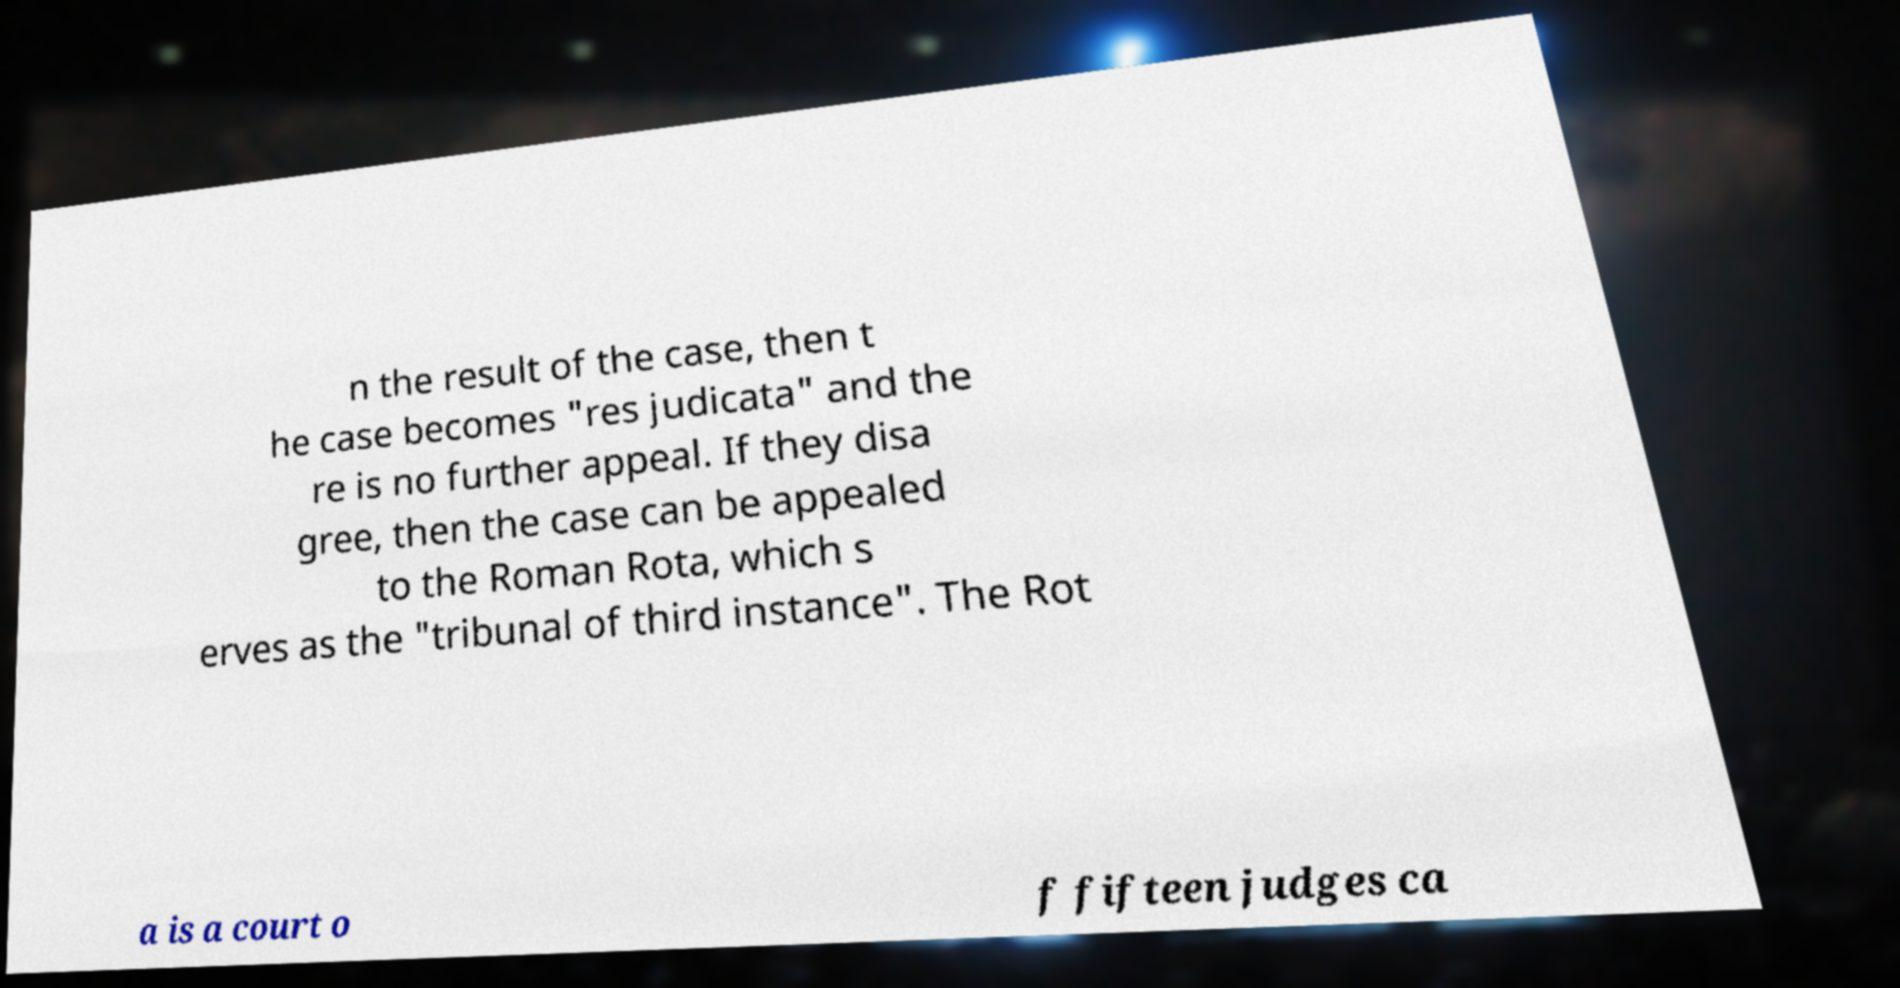I need the written content from this picture converted into text. Can you do that? n the result of the case, then t he case becomes "res judicata" and the re is no further appeal. If they disa gree, then the case can be appealed to the Roman Rota, which s erves as the "tribunal of third instance". The Rot a is a court o f fifteen judges ca 